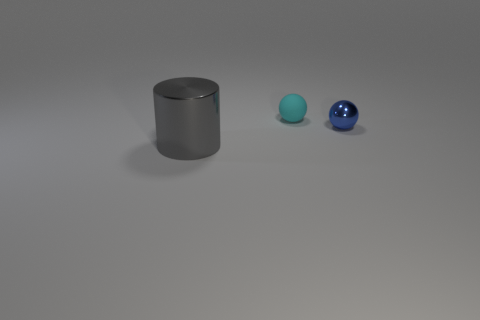Can you tell me about the different objects and their spatial relationships in this image? Certainly! In this image, we have three main objects arranged from left to right: a cyan-colored sphere, a small blue sphere, and a larger blue ball. To the far left is a gray metallic cylinder. The cyan sphere is farthest from the viewer, whilst the other objects are closer, creating a line of objects that draws the eye from left to right. 